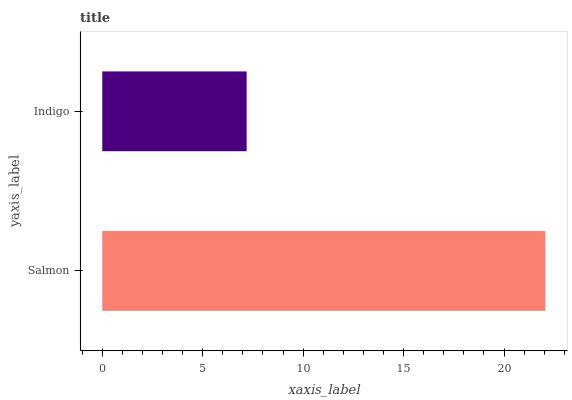Is Indigo the minimum?
Answer yes or no. Yes. Is Salmon the maximum?
Answer yes or no. Yes. Is Indigo the maximum?
Answer yes or no. No. Is Salmon greater than Indigo?
Answer yes or no. Yes. Is Indigo less than Salmon?
Answer yes or no. Yes. Is Indigo greater than Salmon?
Answer yes or no. No. Is Salmon less than Indigo?
Answer yes or no. No. Is Salmon the high median?
Answer yes or no. Yes. Is Indigo the low median?
Answer yes or no. Yes. Is Indigo the high median?
Answer yes or no. No. Is Salmon the low median?
Answer yes or no. No. 